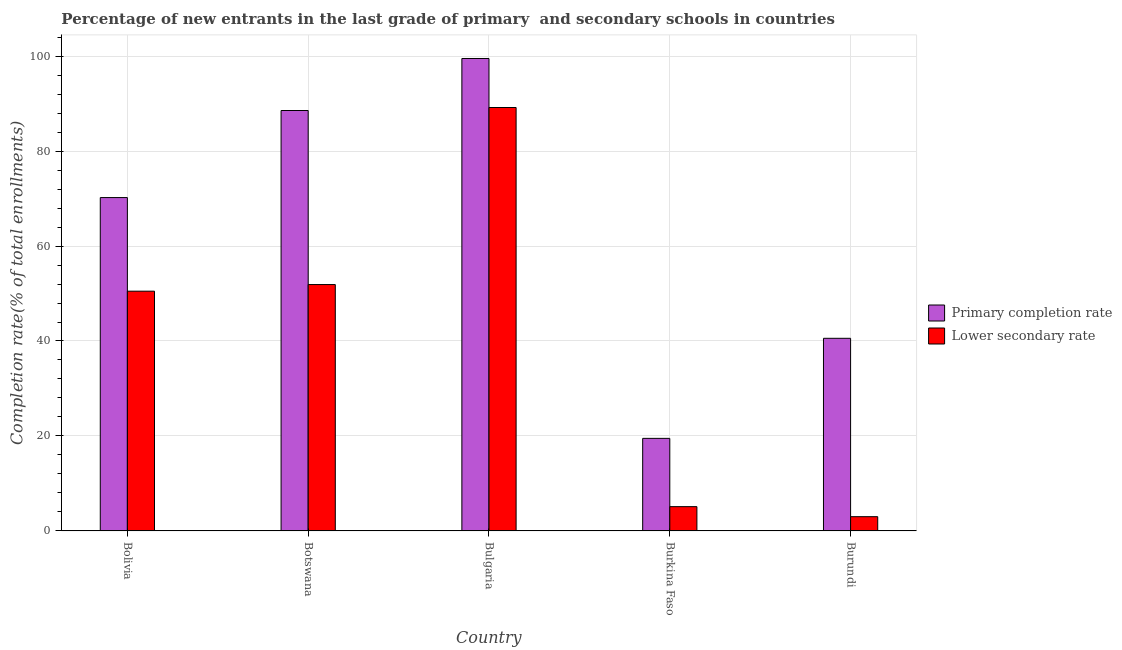How many groups of bars are there?
Keep it short and to the point. 5. Are the number of bars per tick equal to the number of legend labels?
Provide a succinct answer. Yes. How many bars are there on the 2nd tick from the left?
Provide a short and direct response. 2. How many bars are there on the 1st tick from the right?
Keep it short and to the point. 2. What is the label of the 3rd group of bars from the left?
Provide a short and direct response. Bulgaria. In how many cases, is the number of bars for a given country not equal to the number of legend labels?
Your answer should be very brief. 0. What is the completion rate in secondary schools in Burundi?
Make the answer very short. 3. Across all countries, what is the maximum completion rate in primary schools?
Your response must be concise. 99.49. Across all countries, what is the minimum completion rate in secondary schools?
Your answer should be compact. 3. In which country was the completion rate in secondary schools maximum?
Offer a terse response. Bulgaria. In which country was the completion rate in primary schools minimum?
Provide a succinct answer. Burkina Faso. What is the total completion rate in primary schools in the graph?
Provide a succinct answer. 318.3. What is the difference between the completion rate in secondary schools in Bulgaria and that in Burundi?
Offer a terse response. 86.17. What is the difference between the completion rate in secondary schools in Bolivia and the completion rate in primary schools in Burundi?
Offer a very short reply. 9.92. What is the average completion rate in secondary schools per country?
Offer a very short reply. 39.93. What is the difference between the completion rate in secondary schools and completion rate in primary schools in Bulgaria?
Provide a succinct answer. -10.32. What is the ratio of the completion rate in primary schools in Bolivia to that in Burundi?
Offer a very short reply. 1.73. Is the completion rate in secondary schools in Bolivia less than that in Bulgaria?
Your answer should be very brief. Yes. What is the difference between the highest and the second highest completion rate in primary schools?
Provide a short and direct response. 10.95. What is the difference between the highest and the lowest completion rate in primary schools?
Offer a very short reply. 80. What does the 1st bar from the left in Burkina Faso represents?
Keep it short and to the point. Primary completion rate. What does the 1st bar from the right in Botswana represents?
Offer a terse response. Lower secondary rate. How many countries are there in the graph?
Provide a short and direct response. 5. Are the values on the major ticks of Y-axis written in scientific E-notation?
Offer a very short reply. No. Where does the legend appear in the graph?
Your response must be concise. Center right. How many legend labels are there?
Keep it short and to the point. 2. How are the legend labels stacked?
Your answer should be very brief. Vertical. What is the title of the graph?
Provide a short and direct response. Percentage of new entrants in the last grade of primary  and secondary schools in countries. Does "Investment" appear as one of the legend labels in the graph?
Keep it short and to the point. No. What is the label or title of the X-axis?
Provide a short and direct response. Country. What is the label or title of the Y-axis?
Your answer should be compact. Completion rate(% of total enrollments). What is the Completion rate(% of total enrollments) in Primary completion rate in Bolivia?
Your response must be concise. 70.2. What is the Completion rate(% of total enrollments) of Lower secondary rate in Bolivia?
Keep it short and to the point. 50.49. What is the Completion rate(% of total enrollments) in Primary completion rate in Botswana?
Your answer should be very brief. 88.54. What is the Completion rate(% of total enrollments) of Lower secondary rate in Botswana?
Ensure brevity in your answer.  51.89. What is the Completion rate(% of total enrollments) of Primary completion rate in Bulgaria?
Offer a very short reply. 99.49. What is the Completion rate(% of total enrollments) of Lower secondary rate in Bulgaria?
Give a very brief answer. 89.17. What is the Completion rate(% of total enrollments) of Primary completion rate in Burkina Faso?
Offer a terse response. 19.5. What is the Completion rate(% of total enrollments) of Lower secondary rate in Burkina Faso?
Offer a terse response. 5.12. What is the Completion rate(% of total enrollments) of Primary completion rate in Burundi?
Provide a succinct answer. 40.57. What is the Completion rate(% of total enrollments) of Lower secondary rate in Burundi?
Offer a very short reply. 3. Across all countries, what is the maximum Completion rate(% of total enrollments) in Primary completion rate?
Your answer should be compact. 99.49. Across all countries, what is the maximum Completion rate(% of total enrollments) in Lower secondary rate?
Give a very brief answer. 89.17. Across all countries, what is the minimum Completion rate(% of total enrollments) in Primary completion rate?
Offer a terse response. 19.5. Across all countries, what is the minimum Completion rate(% of total enrollments) in Lower secondary rate?
Your response must be concise. 3. What is the total Completion rate(% of total enrollments) in Primary completion rate in the graph?
Give a very brief answer. 318.3. What is the total Completion rate(% of total enrollments) in Lower secondary rate in the graph?
Your answer should be compact. 199.67. What is the difference between the Completion rate(% of total enrollments) of Primary completion rate in Bolivia and that in Botswana?
Provide a succinct answer. -18.34. What is the difference between the Completion rate(% of total enrollments) of Lower secondary rate in Bolivia and that in Botswana?
Provide a succinct answer. -1.4. What is the difference between the Completion rate(% of total enrollments) of Primary completion rate in Bolivia and that in Bulgaria?
Ensure brevity in your answer.  -29.29. What is the difference between the Completion rate(% of total enrollments) in Lower secondary rate in Bolivia and that in Bulgaria?
Your answer should be very brief. -38.68. What is the difference between the Completion rate(% of total enrollments) in Primary completion rate in Bolivia and that in Burkina Faso?
Your response must be concise. 50.71. What is the difference between the Completion rate(% of total enrollments) in Lower secondary rate in Bolivia and that in Burkina Faso?
Offer a very short reply. 45.37. What is the difference between the Completion rate(% of total enrollments) of Primary completion rate in Bolivia and that in Burundi?
Keep it short and to the point. 29.64. What is the difference between the Completion rate(% of total enrollments) in Lower secondary rate in Bolivia and that in Burundi?
Provide a succinct answer. 47.49. What is the difference between the Completion rate(% of total enrollments) in Primary completion rate in Botswana and that in Bulgaria?
Provide a short and direct response. -10.95. What is the difference between the Completion rate(% of total enrollments) in Lower secondary rate in Botswana and that in Bulgaria?
Offer a very short reply. -37.28. What is the difference between the Completion rate(% of total enrollments) in Primary completion rate in Botswana and that in Burkina Faso?
Make the answer very short. 69.05. What is the difference between the Completion rate(% of total enrollments) of Lower secondary rate in Botswana and that in Burkina Faso?
Offer a very short reply. 46.77. What is the difference between the Completion rate(% of total enrollments) of Primary completion rate in Botswana and that in Burundi?
Your answer should be compact. 47.97. What is the difference between the Completion rate(% of total enrollments) in Lower secondary rate in Botswana and that in Burundi?
Keep it short and to the point. 48.88. What is the difference between the Completion rate(% of total enrollments) in Primary completion rate in Bulgaria and that in Burkina Faso?
Provide a short and direct response. 80. What is the difference between the Completion rate(% of total enrollments) in Lower secondary rate in Bulgaria and that in Burkina Faso?
Make the answer very short. 84.05. What is the difference between the Completion rate(% of total enrollments) in Primary completion rate in Bulgaria and that in Burundi?
Provide a succinct answer. 58.93. What is the difference between the Completion rate(% of total enrollments) of Lower secondary rate in Bulgaria and that in Burundi?
Ensure brevity in your answer.  86.17. What is the difference between the Completion rate(% of total enrollments) of Primary completion rate in Burkina Faso and that in Burundi?
Make the answer very short. -21.07. What is the difference between the Completion rate(% of total enrollments) in Lower secondary rate in Burkina Faso and that in Burundi?
Keep it short and to the point. 2.11. What is the difference between the Completion rate(% of total enrollments) of Primary completion rate in Bolivia and the Completion rate(% of total enrollments) of Lower secondary rate in Botswana?
Offer a terse response. 18.32. What is the difference between the Completion rate(% of total enrollments) in Primary completion rate in Bolivia and the Completion rate(% of total enrollments) in Lower secondary rate in Bulgaria?
Your answer should be compact. -18.97. What is the difference between the Completion rate(% of total enrollments) in Primary completion rate in Bolivia and the Completion rate(% of total enrollments) in Lower secondary rate in Burkina Faso?
Make the answer very short. 65.09. What is the difference between the Completion rate(% of total enrollments) in Primary completion rate in Bolivia and the Completion rate(% of total enrollments) in Lower secondary rate in Burundi?
Make the answer very short. 67.2. What is the difference between the Completion rate(% of total enrollments) in Primary completion rate in Botswana and the Completion rate(% of total enrollments) in Lower secondary rate in Bulgaria?
Your answer should be very brief. -0.63. What is the difference between the Completion rate(% of total enrollments) in Primary completion rate in Botswana and the Completion rate(% of total enrollments) in Lower secondary rate in Burkina Faso?
Make the answer very short. 83.42. What is the difference between the Completion rate(% of total enrollments) of Primary completion rate in Botswana and the Completion rate(% of total enrollments) of Lower secondary rate in Burundi?
Your answer should be very brief. 85.54. What is the difference between the Completion rate(% of total enrollments) of Primary completion rate in Bulgaria and the Completion rate(% of total enrollments) of Lower secondary rate in Burkina Faso?
Offer a very short reply. 94.38. What is the difference between the Completion rate(% of total enrollments) in Primary completion rate in Bulgaria and the Completion rate(% of total enrollments) in Lower secondary rate in Burundi?
Provide a short and direct response. 96.49. What is the difference between the Completion rate(% of total enrollments) of Primary completion rate in Burkina Faso and the Completion rate(% of total enrollments) of Lower secondary rate in Burundi?
Keep it short and to the point. 16.49. What is the average Completion rate(% of total enrollments) in Primary completion rate per country?
Offer a terse response. 63.66. What is the average Completion rate(% of total enrollments) in Lower secondary rate per country?
Your answer should be very brief. 39.93. What is the difference between the Completion rate(% of total enrollments) in Primary completion rate and Completion rate(% of total enrollments) in Lower secondary rate in Bolivia?
Provide a short and direct response. 19.71. What is the difference between the Completion rate(% of total enrollments) of Primary completion rate and Completion rate(% of total enrollments) of Lower secondary rate in Botswana?
Provide a short and direct response. 36.65. What is the difference between the Completion rate(% of total enrollments) in Primary completion rate and Completion rate(% of total enrollments) in Lower secondary rate in Bulgaria?
Offer a very short reply. 10.32. What is the difference between the Completion rate(% of total enrollments) in Primary completion rate and Completion rate(% of total enrollments) in Lower secondary rate in Burkina Faso?
Your answer should be very brief. 14.38. What is the difference between the Completion rate(% of total enrollments) in Primary completion rate and Completion rate(% of total enrollments) in Lower secondary rate in Burundi?
Offer a very short reply. 37.56. What is the ratio of the Completion rate(% of total enrollments) of Primary completion rate in Bolivia to that in Botswana?
Provide a short and direct response. 0.79. What is the ratio of the Completion rate(% of total enrollments) in Lower secondary rate in Bolivia to that in Botswana?
Give a very brief answer. 0.97. What is the ratio of the Completion rate(% of total enrollments) of Primary completion rate in Bolivia to that in Bulgaria?
Ensure brevity in your answer.  0.71. What is the ratio of the Completion rate(% of total enrollments) of Lower secondary rate in Bolivia to that in Bulgaria?
Provide a short and direct response. 0.57. What is the ratio of the Completion rate(% of total enrollments) in Primary completion rate in Bolivia to that in Burkina Faso?
Make the answer very short. 3.6. What is the ratio of the Completion rate(% of total enrollments) of Lower secondary rate in Bolivia to that in Burkina Faso?
Make the answer very short. 9.87. What is the ratio of the Completion rate(% of total enrollments) in Primary completion rate in Bolivia to that in Burundi?
Your answer should be compact. 1.73. What is the ratio of the Completion rate(% of total enrollments) in Lower secondary rate in Bolivia to that in Burundi?
Offer a terse response. 16.81. What is the ratio of the Completion rate(% of total enrollments) of Primary completion rate in Botswana to that in Bulgaria?
Ensure brevity in your answer.  0.89. What is the ratio of the Completion rate(% of total enrollments) of Lower secondary rate in Botswana to that in Bulgaria?
Offer a terse response. 0.58. What is the ratio of the Completion rate(% of total enrollments) in Primary completion rate in Botswana to that in Burkina Faso?
Offer a very short reply. 4.54. What is the ratio of the Completion rate(% of total enrollments) of Lower secondary rate in Botswana to that in Burkina Faso?
Make the answer very short. 10.14. What is the ratio of the Completion rate(% of total enrollments) of Primary completion rate in Botswana to that in Burundi?
Your answer should be very brief. 2.18. What is the ratio of the Completion rate(% of total enrollments) in Lower secondary rate in Botswana to that in Burundi?
Your answer should be very brief. 17.28. What is the ratio of the Completion rate(% of total enrollments) in Primary completion rate in Bulgaria to that in Burkina Faso?
Provide a short and direct response. 5.1. What is the ratio of the Completion rate(% of total enrollments) of Lower secondary rate in Bulgaria to that in Burkina Faso?
Offer a terse response. 17.43. What is the ratio of the Completion rate(% of total enrollments) of Primary completion rate in Bulgaria to that in Burundi?
Your response must be concise. 2.45. What is the ratio of the Completion rate(% of total enrollments) of Lower secondary rate in Bulgaria to that in Burundi?
Your answer should be very brief. 29.69. What is the ratio of the Completion rate(% of total enrollments) in Primary completion rate in Burkina Faso to that in Burundi?
Ensure brevity in your answer.  0.48. What is the ratio of the Completion rate(% of total enrollments) in Lower secondary rate in Burkina Faso to that in Burundi?
Provide a succinct answer. 1.7. What is the difference between the highest and the second highest Completion rate(% of total enrollments) in Primary completion rate?
Keep it short and to the point. 10.95. What is the difference between the highest and the second highest Completion rate(% of total enrollments) in Lower secondary rate?
Make the answer very short. 37.28. What is the difference between the highest and the lowest Completion rate(% of total enrollments) of Primary completion rate?
Provide a succinct answer. 80. What is the difference between the highest and the lowest Completion rate(% of total enrollments) of Lower secondary rate?
Give a very brief answer. 86.17. 